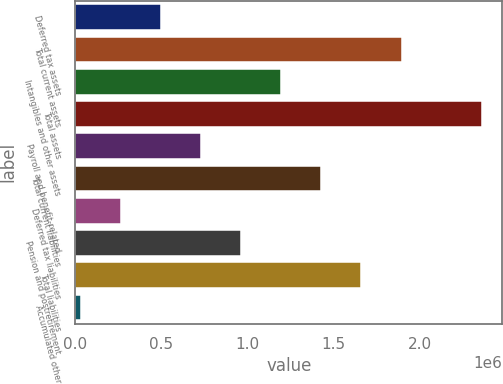Convert chart. <chart><loc_0><loc_0><loc_500><loc_500><bar_chart><fcel>Deferred tax assets<fcel>Total current assets<fcel>Intangibles and other assets<fcel>Total assets<fcel>Payroll and benefit-related<fcel>Total current liabilities<fcel>Deferred tax liabilities<fcel>Pension and postretirement<fcel>Total liabilities<fcel>Accumulated other<nl><fcel>495838<fcel>1.89325e+06<fcel>1.19454e+06<fcel>2.35905e+06<fcel>728740<fcel>1.42745e+06<fcel>262937<fcel>961642<fcel>1.66035e+06<fcel>30035<nl></chart> 